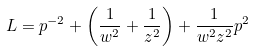<formula> <loc_0><loc_0><loc_500><loc_500>L = p ^ { - 2 } + \left ( \frac { 1 } { w ^ { 2 } } + \frac { 1 } { z ^ { 2 } } \right ) + \frac { 1 } { w ^ { 2 } z ^ { 2 } } p ^ { 2 }</formula> 